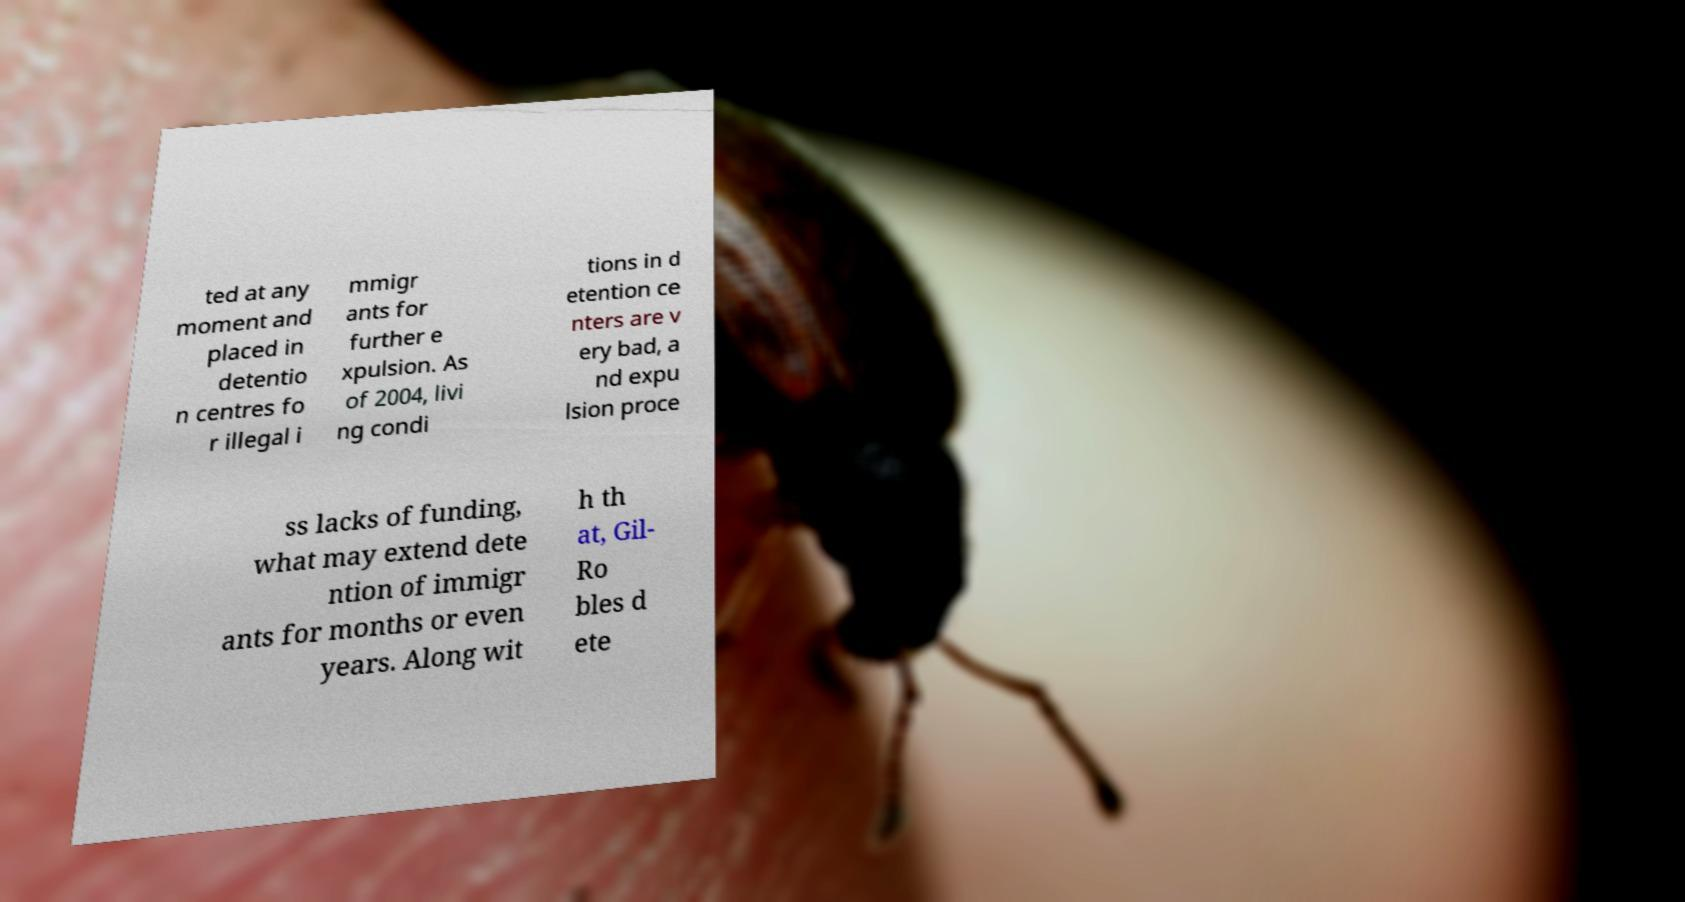Could you extract and type out the text from this image? ted at any moment and placed in detentio n centres fo r illegal i mmigr ants for further e xpulsion. As of 2004, livi ng condi tions in d etention ce nters are v ery bad, a nd expu lsion proce ss lacks of funding, what may extend dete ntion of immigr ants for months or even years. Along wit h th at, Gil- Ro bles d ete 